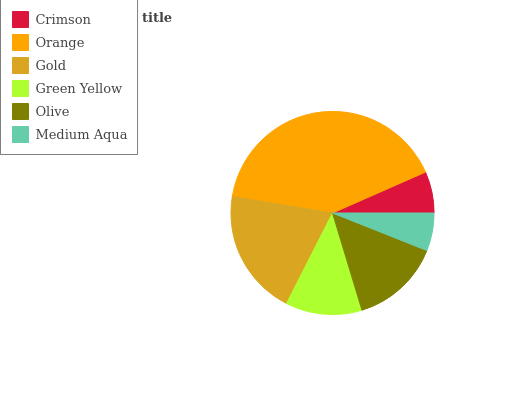Is Medium Aqua the minimum?
Answer yes or no. Yes. Is Orange the maximum?
Answer yes or no. Yes. Is Gold the minimum?
Answer yes or no. No. Is Gold the maximum?
Answer yes or no. No. Is Orange greater than Gold?
Answer yes or no. Yes. Is Gold less than Orange?
Answer yes or no. Yes. Is Gold greater than Orange?
Answer yes or no. No. Is Orange less than Gold?
Answer yes or no. No. Is Olive the high median?
Answer yes or no. Yes. Is Green Yellow the low median?
Answer yes or no. Yes. Is Green Yellow the high median?
Answer yes or no. No. Is Orange the low median?
Answer yes or no. No. 